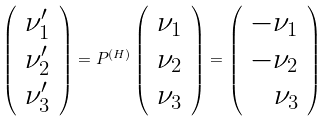<formula> <loc_0><loc_0><loc_500><loc_500>\left ( \begin{array} { r } \nu ^ { \prime } _ { 1 } \\ \nu ^ { \prime } _ { 2 } \\ \nu ^ { \prime } _ { 3 } \end{array} \right ) = P ^ { ( H ) } \left ( \begin{array} { r } \nu _ { 1 } \\ \nu _ { 2 } \\ \nu _ { 3 } \end{array} \right ) = \left ( \begin{array} { r } - \nu _ { 1 } \\ - \nu _ { 2 } \\ \nu _ { 3 } \end{array} \right )</formula> 